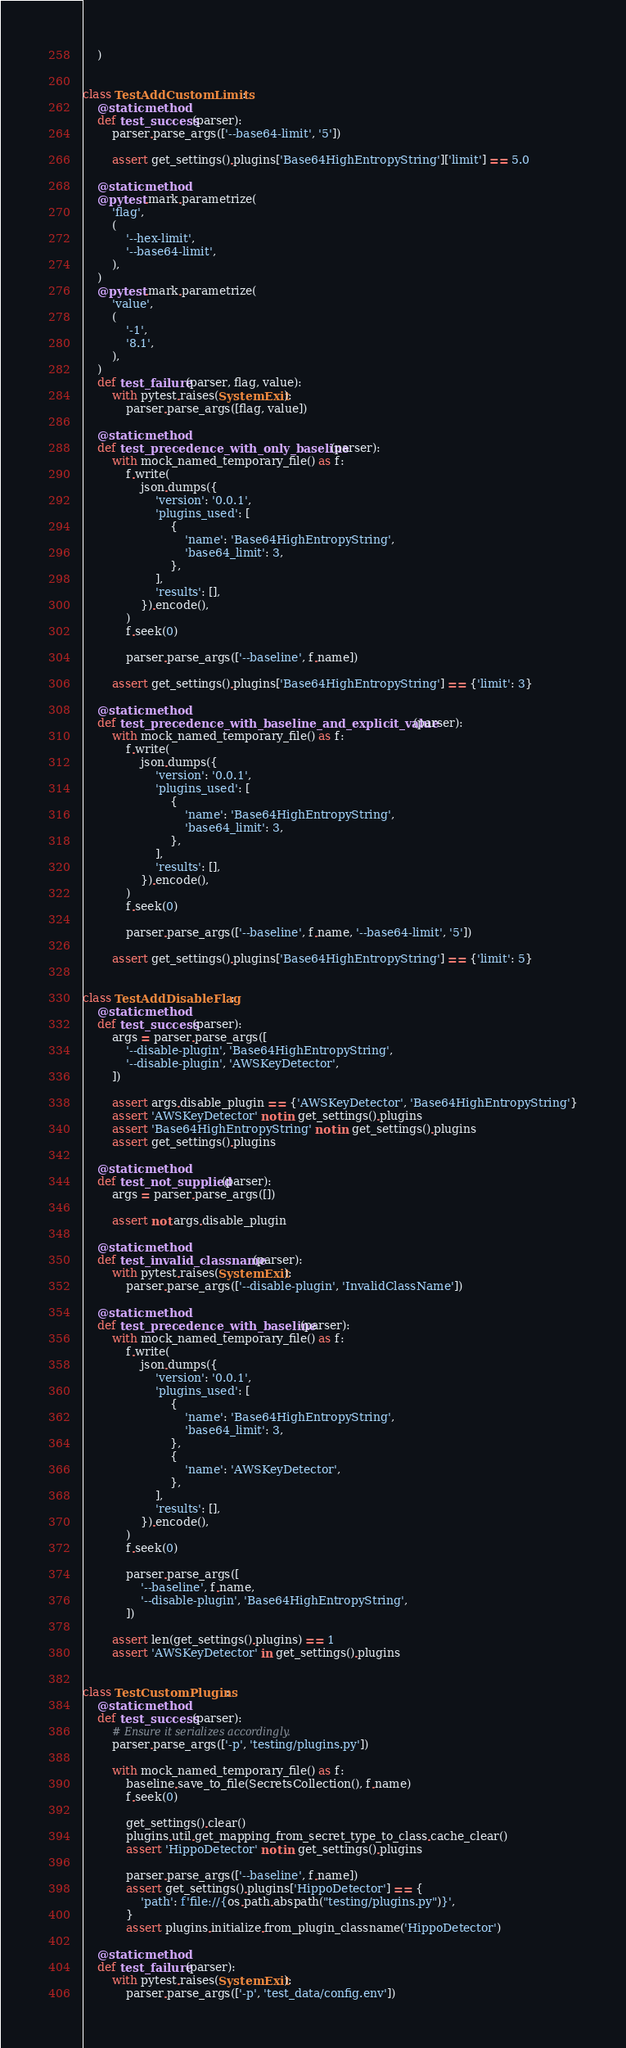Convert code to text. <code><loc_0><loc_0><loc_500><loc_500><_Python_>    )


class TestAddCustomLimits:
    @staticmethod
    def test_success(parser):
        parser.parse_args(['--base64-limit', '5'])

        assert get_settings().plugins['Base64HighEntropyString']['limit'] == 5.0

    @staticmethod
    @pytest.mark.parametrize(
        'flag',
        (
            '--hex-limit',
            '--base64-limit',
        ),
    )
    @pytest.mark.parametrize(
        'value',
        (
            '-1',
            '8.1',
        ),
    )
    def test_failure(parser, flag, value):
        with pytest.raises(SystemExit):
            parser.parse_args([flag, value])

    @staticmethod
    def test_precedence_with_only_baseline(parser):
        with mock_named_temporary_file() as f:
            f.write(
                json.dumps({
                    'version': '0.0.1',
                    'plugins_used': [
                        {
                            'name': 'Base64HighEntropyString',
                            'base64_limit': 3,
                        },
                    ],
                    'results': [],
                }).encode(),
            )
            f.seek(0)

            parser.parse_args(['--baseline', f.name])

        assert get_settings().plugins['Base64HighEntropyString'] == {'limit': 3}

    @staticmethod
    def test_precedence_with_baseline_and_explicit_value(parser):
        with mock_named_temporary_file() as f:
            f.write(
                json.dumps({
                    'version': '0.0.1',
                    'plugins_used': [
                        {
                            'name': 'Base64HighEntropyString',
                            'base64_limit': 3,
                        },
                    ],
                    'results': [],
                }).encode(),
            )
            f.seek(0)

            parser.parse_args(['--baseline', f.name, '--base64-limit', '5'])

        assert get_settings().plugins['Base64HighEntropyString'] == {'limit': 5}


class TestAddDisableFlag:
    @staticmethod
    def test_success(parser):
        args = parser.parse_args([
            '--disable-plugin', 'Base64HighEntropyString',
            '--disable-plugin', 'AWSKeyDetector',
        ])

        assert args.disable_plugin == {'AWSKeyDetector', 'Base64HighEntropyString'}
        assert 'AWSKeyDetector' not in get_settings().plugins
        assert 'Base64HighEntropyString' not in get_settings().plugins
        assert get_settings().plugins

    @staticmethod
    def test_not_supplied(parser):
        args = parser.parse_args([])

        assert not args.disable_plugin

    @staticmethod
    def test_invalid_classname(parser):
        with pytest.raises(SystemExit):
            parser.parse_args(['--disable-plugin', 'InvalidClassName'])

    @staticmethod
    def test_precedence_with_baseline(parser):
        with mock_named_temporary_file() as f:
            f.write(
                json.dumps({
                    'version': '0.0.1',
                    'plugins_used': [
                        {
                            'name': 'Base64HighEntropyString',
                            'base64_limit': 3,
                        },
                        {
                            'name': 'AWSKeyDetector',
                        },
                    ],
                    'results': [],
                }).encode(),
            )
            f.seek(0)

            parser.parse_args([
                '--baseline', f.name,
                '--disable-plugin', 'Base64HighEntropyString',
            ])

        assert len(get_settings().plugins) == 1
        assert 'AWSKeyDetector' in get_settings().plugins


class TestCustomPlugins:
    @staticmethod
    def test_success(parser):
        # Ensure it serializes accordingly.
        parser.parse_args(['-p', 'testing/plugins.py'])

        with mock_named_temporary_file() as f:
            baseline.save_to_file(SecretsCollection(), f.name)
            f.seek(0)

            get_settings().clear()
            plugins.util.get_mapping_from_secret_type_to_class.cache_clear()
            assert 'HippoDetector' not in get_settings().plugins

            parser.parse_args(['--baseline', f.name])
            assert get_settings().plugins['HippoDetector'] == {
                'path': f'file://{os.path.abspath("testing/plugins.py")}',
            }
            assert plugins.initialize.from_plugin_classname('HippoDetector')

    @staticmethod
    def test_failure(parser):
        with pytest.raises(SystemExit):
            parser.parse_args(['-p', 'test_data/config.env'])
</code> 